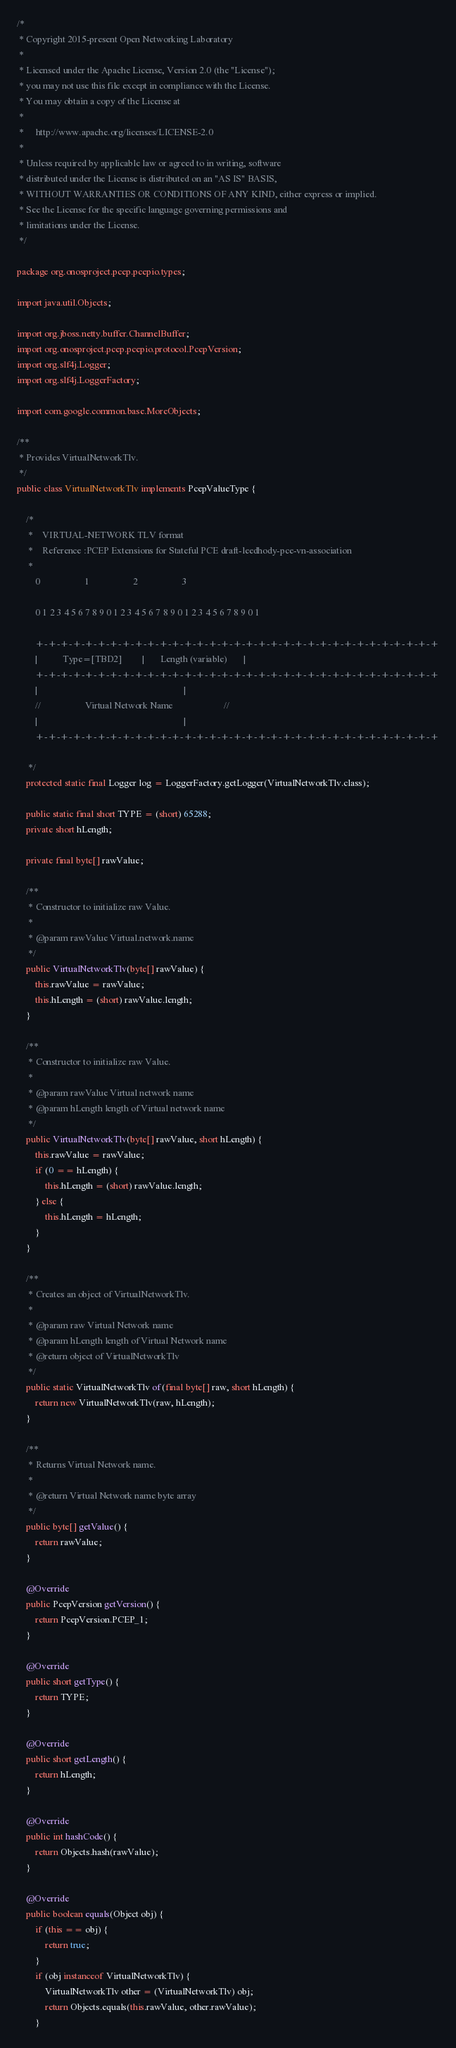<code> <loc_0><loc_0><loc_500><loc_500><_Java_>/*
 * Copyright 2015-present Open Networking Laboratory
 *
 * Licensed under the Apache License, Version 2.0 (the "License");
 * you may not use this file except in compliance with the License.
 * You may obtain a copy of the License at
 *
 *     http://www.apache.org/licenses/LICENSE-2.0
 *
 * Unless required by applicable law or agreed to in writing, software
 * distributed under the License is distributed on an "AS IS" BASIS,
 * WITHOUT WARRANTIES OR CONDITIONS OF ANY KIND, either express or implied.
 * See the License for the specific language governing permissions and
 * limitations under the License.
 */

package org.onosproject.pcep.pcepio.types;

import java.util.Objects;

import org.jboss.netty.buffer.ChannelBuffer;
import org.onosproject.pcep.pcepio.protocol.PcepVersion;
import org.slf4j.Logger;
import org.slf4j.LoggerFactory;

import com.google.common.base.MoreObjects;

/**
 * Provides VirtualNetworkTlv.
 */
public class VirtualNetworkTlv implements PcepValueType {

    /*
     *    VIRTUAL-NETWORK TLV format
     *    Reference :PCEP Extensions for Stateful PCE draft-leedhody-pce-vn-association
     *
        0                   1                   2                   3

        0 1 2 3 4 5 6 7 8 9 0 1 2 3 4 5 6 7 8 9 0 1 2 3 4 5 6 7 8 9 0 1

        +-+-+-+-+-+-+-+-+-+-+-+-+-+-+-+-+-+-+-+-+-+-+-+-+-+-+-+-+-+-+-+-+
        |           Type=[TBD2]         |       Length (variable)       |
        +-+-+-+-+-+-+-+-+-+-+-+-+-+-+-+-+-+-+-+-+-+-+-+-+-+-+-+-+-+-+-+-+
        |                                                               |
        //                   Virtual Network Name                      //
        |                                                               |
        +-+-+-+-+-+-+-+-+-+-+-+-+-+-+-+-+-+-+-+-+-+-+-+-+-+-+-+-+-+-+-+-+

     */
    protected static final Logger log = LoggerFactory.getLogger(VirtualNetworkTlv.class);

    public static final short TYPE = (short) 65288;
    private short hLength;

    private final byte[] rawValue;

    /**
     * Constructor to initialize raw Value.
     *
     * @param rawValue Virtual.network.name
     */
    public VirtualNetworkTlv(byte[] rawValue) {
        this.rawValue = rawValue;
        this.hLength = (short) rawValue.length;
    }

    /**
     * Constructor to initialize raw Value.
     *
     * @param rawValue Virtual network name
     * @param hLength length of Virtual network name
     */
    public VirtualNetworkTlv(byte[] rawValue, short hLength) {
        this.rawValue = rawValue;
        if (0 == hLength) {
            this.hLength = (short) rawValue.length;
        } else {
            this.hLength = hLength;
        }
    }

    /**
     * Creates an object of VirtualNetworkTlv.
     *
     * @param raw Virtual Network name
     * @param hLength length of Virtual Network name
     * @return object of VirtualNetworkTlv
     */
    public static VirtualNetworkTlv of(final byte[] raw, short hLength) {
        return new VirtualNetworkTlv(raw, hLength);
    }

    /**
     * Returns Virtual Network name.
     *
     * @return Virtual Network name byte array
     */
    public byte[] getValue() {
        return rawValue;
    }

    @Override
    public PcepVersion getVersion() {
        return PcepVersion.PCEP_1;
    }

    @Override
    public short getType() {
        return TYPE;
    }

    @Override
    public short getLength() {
        return hLength;
    }

    @Override
    public int hashCode() {
        return Objects.hash(rawValue);
    }

    @Override
    public boolean equals(Object obj) {
        if (this == obj) {
            return true;
        }
        if (obj instanceof VirtualNetworkTlv) {
            VirtualNetworkTlv other = (VirtualNetworkTlv) obj;
            return Objects.equals(this.rawValue, other.rawValue);
        }</code> 